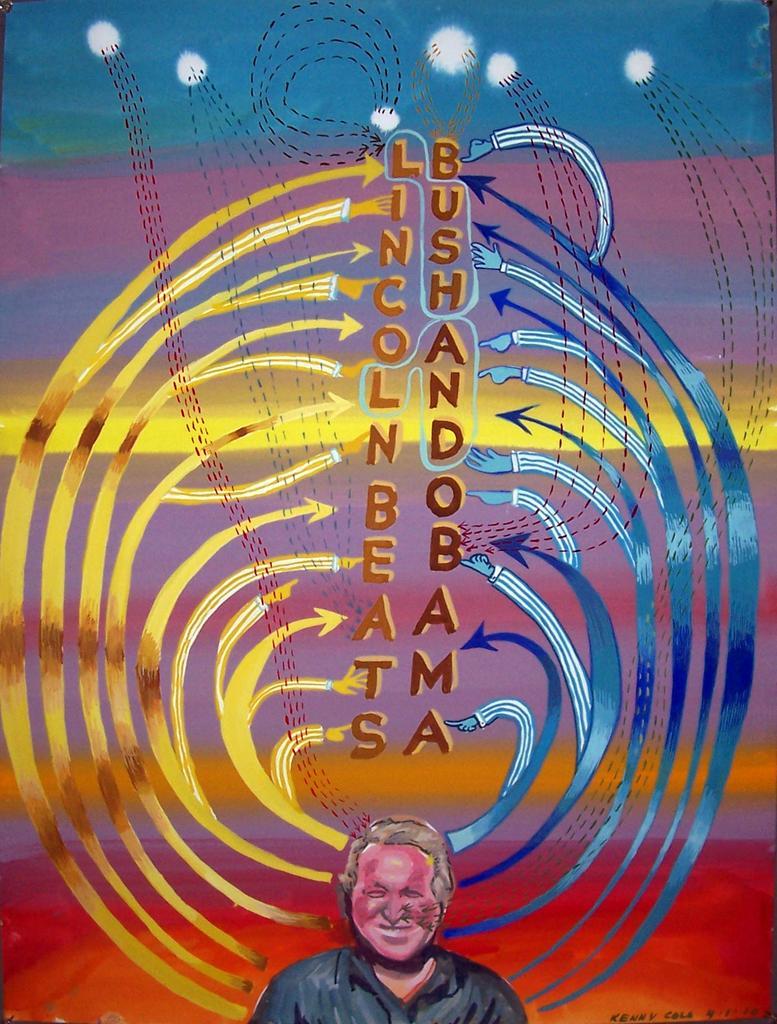Can you describe this image briefly? In this picture I can see there is a man standing and smiling and there is a decoration on the wall. 